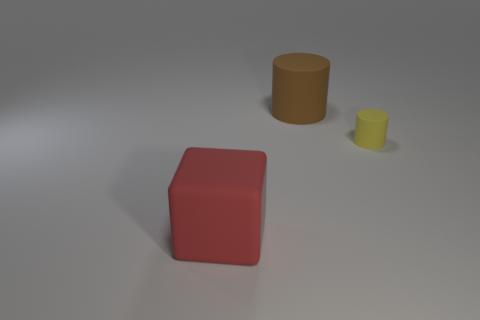Add 2 big brown cylinders. How many objects exist? 5 Subtract all blocks. How many objects are left? 2 Subtract 0 cyan blocks. How many objects are left? 3 Subtract all brown matte cylinders. Subtract all small brown matte cubes. How many objects are left? 2 Add 3 large matte cylinders. How many large matte cylinders are left? 4 Add 2 large red blocks. How many large red blocks exist? 3 